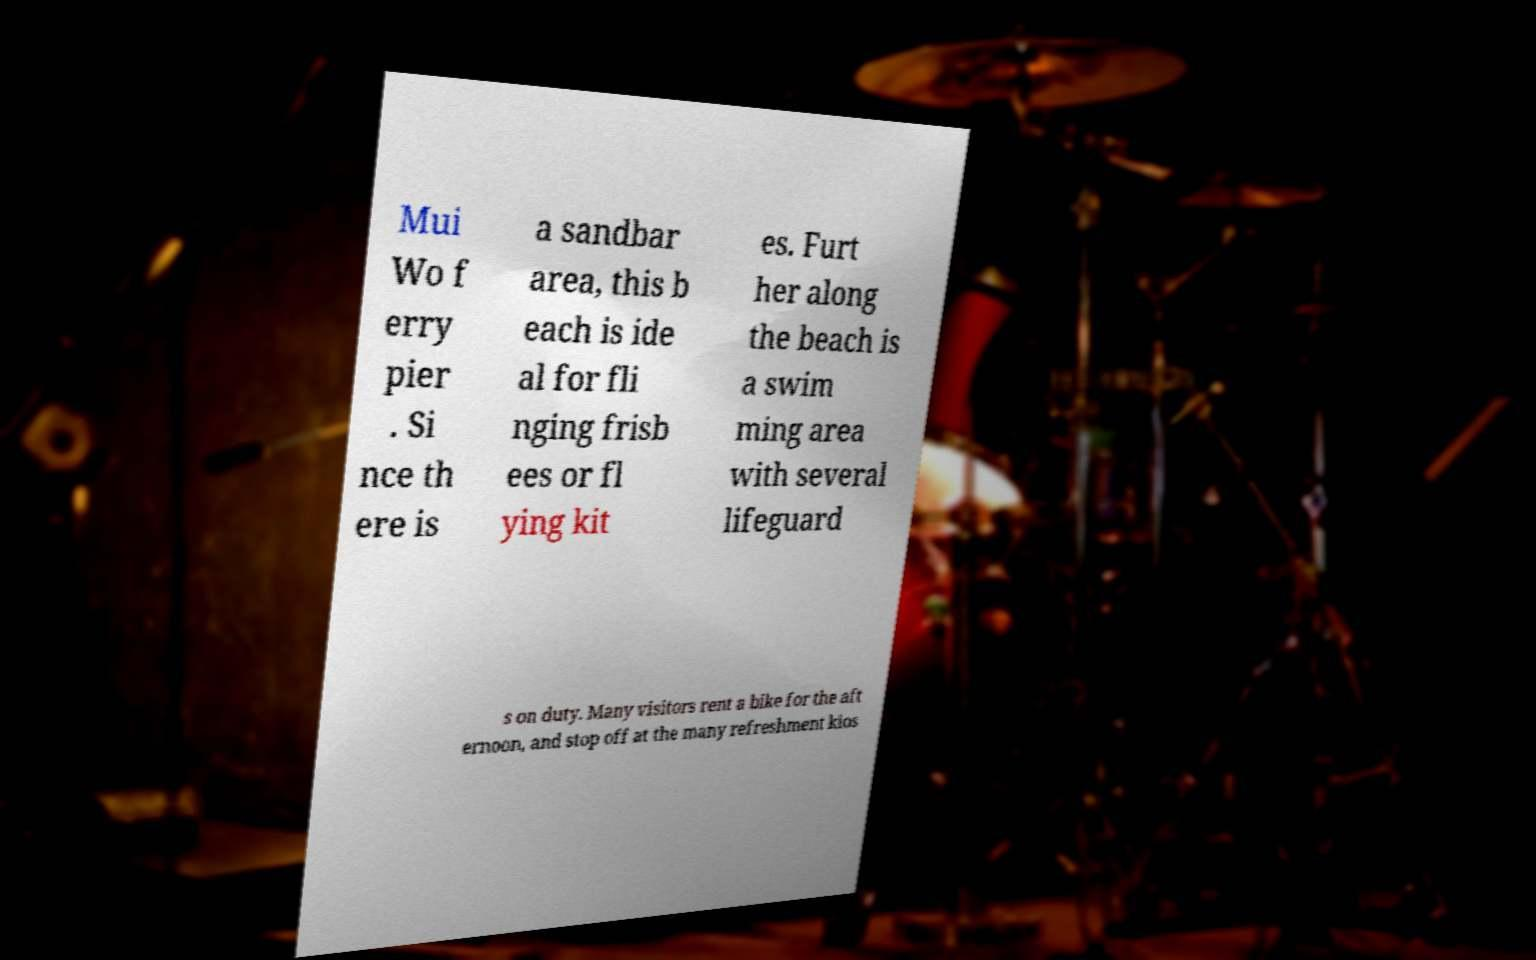Please identify and transcribe the text found in this image. Mui Wo f erry pier . Si nce th ere is a sandbar area, this b each is ide al for fli nging frisb ees or fl ying kit es. Furt her along the beach is a swim ming area with several lifeguard s on duty. Many visitors rent a bike for the aft ernoon, and stop off at the many refreshment kios 